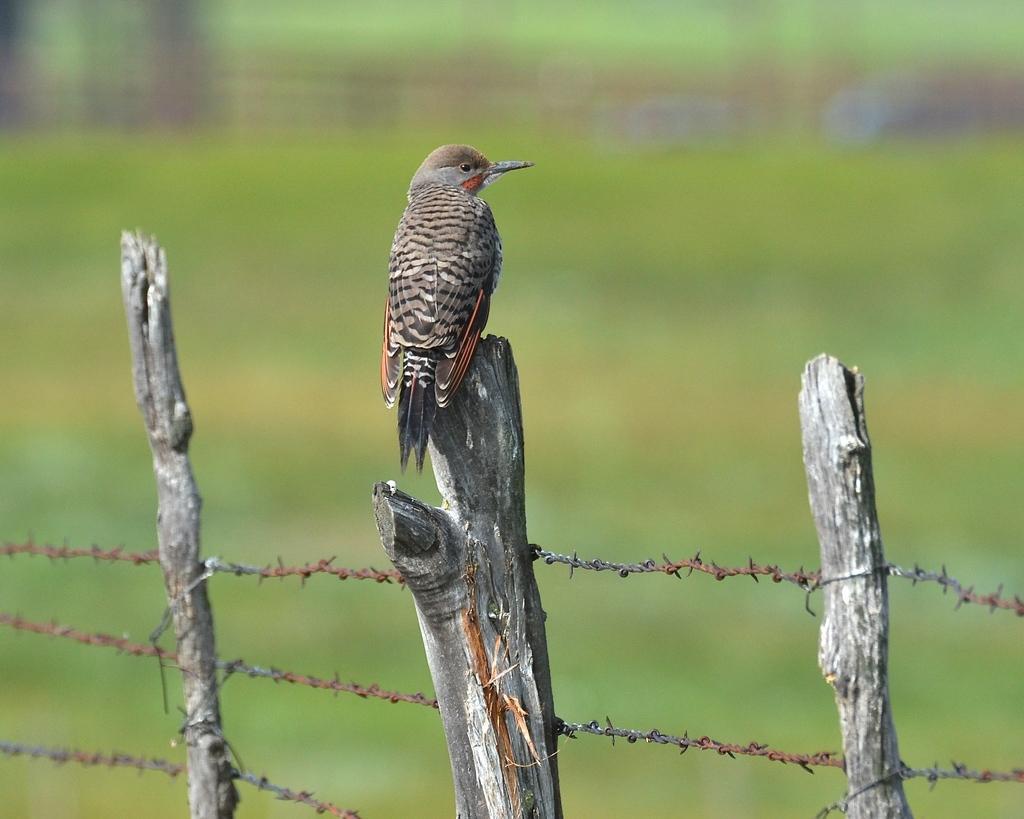Describe this image in one or two sentences. In this picture there is a bird standing on the tree branch. In the foreground there is a fence. At the back image is blurry. 